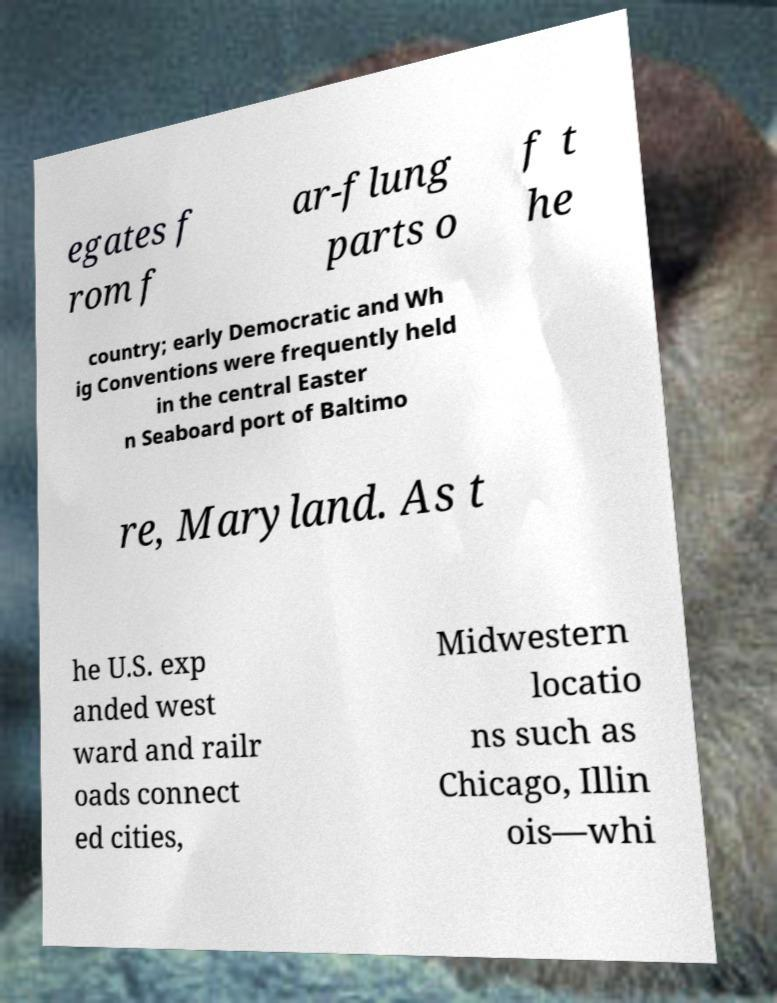There's text embedded in this image that I need extracted. Can you transcribe it verbatim? egates f rom f ar-flung parts o f t he country; early Democratic and Wh ig Conventions were frequently held in the central Easter n Seaboard port of Baltimo re, Maryland. As t he U.S. exp anded west ward and railr oads connect ed cities, Midwestern locatio ns such as Chicago, Illin ois—whi 